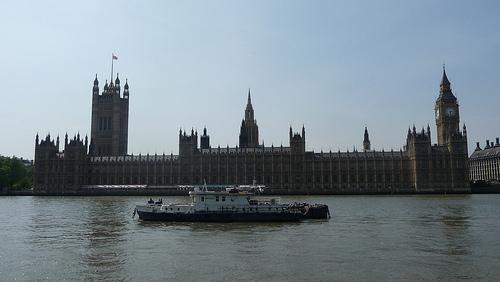How many boats are visible?
Give a very brief answer. 1. 